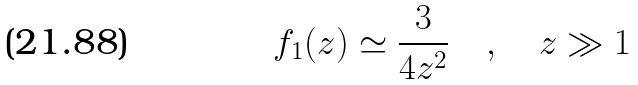<formula> <loc_0><loc_0><loc_500><loc_500>f _ { 1 } ( z ) \simeq \frac { 3 } { 4 z ^ { 2 } } \quad , \quad z \gg 1</formula> 